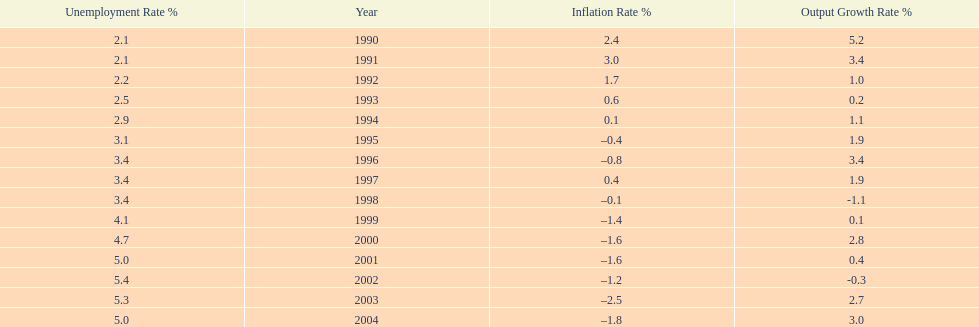What year had the highest unemployment rate? 2002. Write the full table. {'header': ['Unemployment Rate\xa0%', 'Year', 'Inflation Rate\xa0%', 'Output Growth Rate\xa0%'], 'rows': [['2.1', '1990', '2.4', '5.2'], ['2.1', '1991', '3.0', '3.4'], ['2.2', '1992', '1.7', '1.0'], ['2.5', '1993', '0.6', '0.2'], ['2.9', '1994', '0.1', '1.1'], ['3.1', '1995', '–0.4', '1.9'], ['3.4', '1996', '–0.8', '3.4'], ['3.4', '1997', '0.4', '1.9'], ['3.4', '1998', '–0.1', '-1.1'], ['4.1', '1999', '–1.4', '0.1'], ['4.7', '2000', '–1.6', '2.8'], ['5.0', '2001', '–1.6', '0.4'], ['5.4', '2002', '–1.2', '-0.3'], ['5.3', '2003', '–2.5', '2.7'], ['5.0', '2004', '–1.8', '3.0']]} 